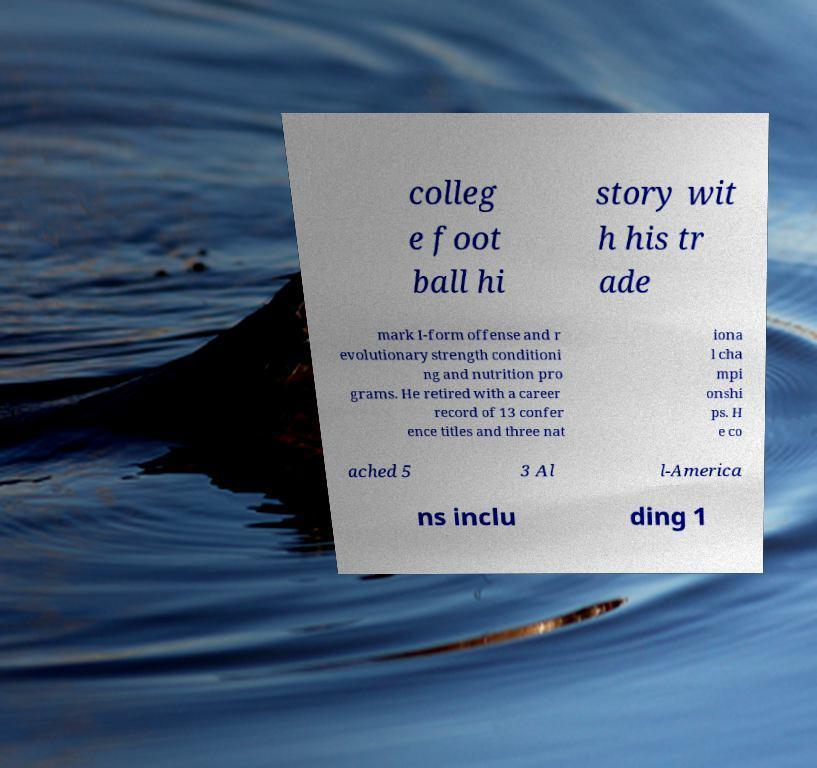Please read and relay the text visible in this image. What does it say? colleg e foot ball hi story wit h his tr ade mark I-form offense and r evolutionary strength conditioni ng and nutrition pro grams. He retired with a career record of 13 confer ence titles and three nat iona l cha mpi onshi ps. H e co ached 5 3 Al l-America ns inclu ding 1 